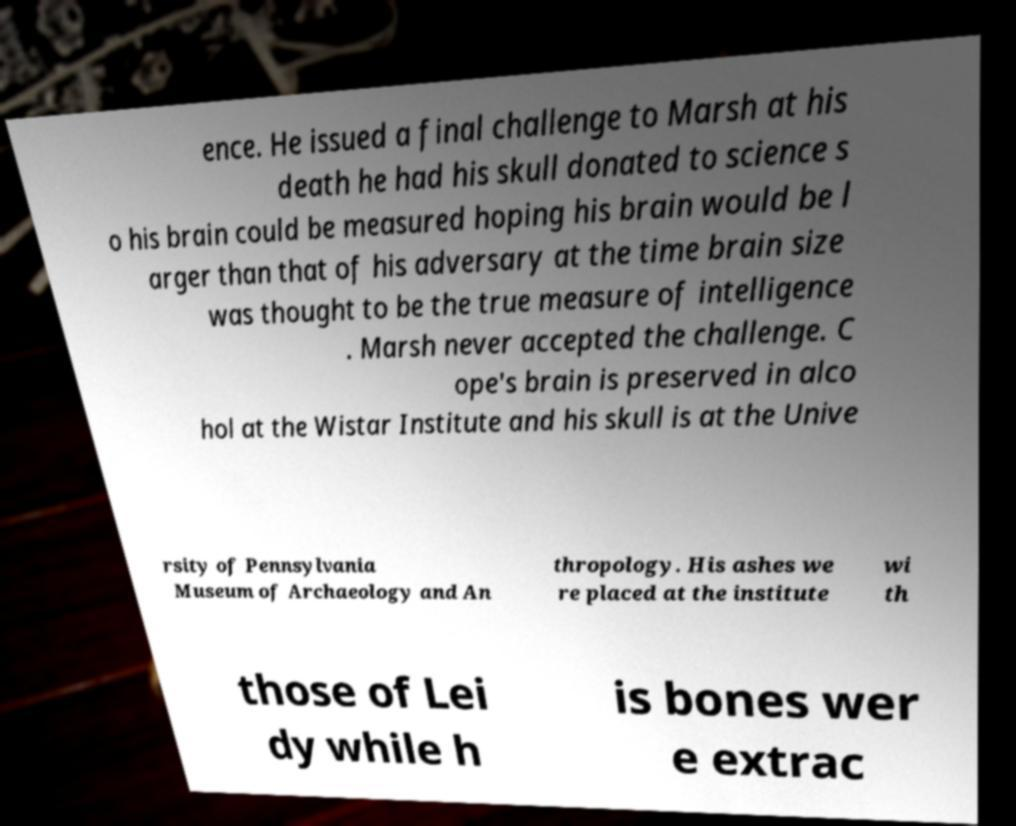Can you read and provide the text displayed in the image?This photo seems to have some interesting text. Can you extract and type it out for me? ence. He issued a final challenge to Marsh at his death he had his skull donated to science s o his brain could be measured hoping his brain would be l arger than that of his adversary at the time brain size was thought to be the true measure of intelligence . Marsh never accepted the challenge. C ope's brain is preserved in alco hol at the Wistar Institute and his skull is at the Unive rsity of Pennsylvania Museum of Archaeology and An thropology. His ashes we re placed at the institute wi th those of Lei dy while h is bones wer e extrac 